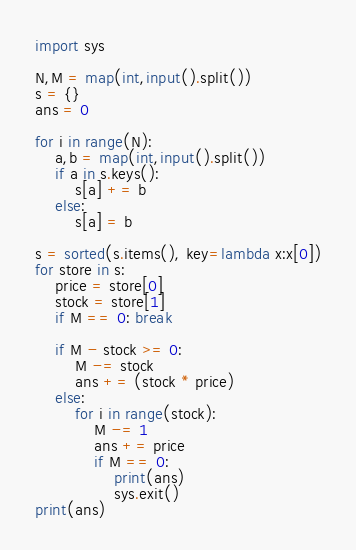<code> <loc_0><loc_0><loc_500><loc_500><_Python_>import sys

N,M = map(int,input().split())
s = {}
ans = 0

for i in range(N):
	a,b = map(int,input().split())
	if a in s.keys():
		s[a] += b
	else:
		s[a] = b

s = sorted(s.items(), key=lambda x:x[0])
for store in s:
	price = store[0]
	stock = store[1]
	if M == 0: break

	if M - stock >= 0:
		M -= stock
		ans += (stock * price)
	else:
		for i in range(stock):
			M -= 1
			ans += price
			if M == 0:
				print(ans)
				sys.exit()
print(ans)
</code> 